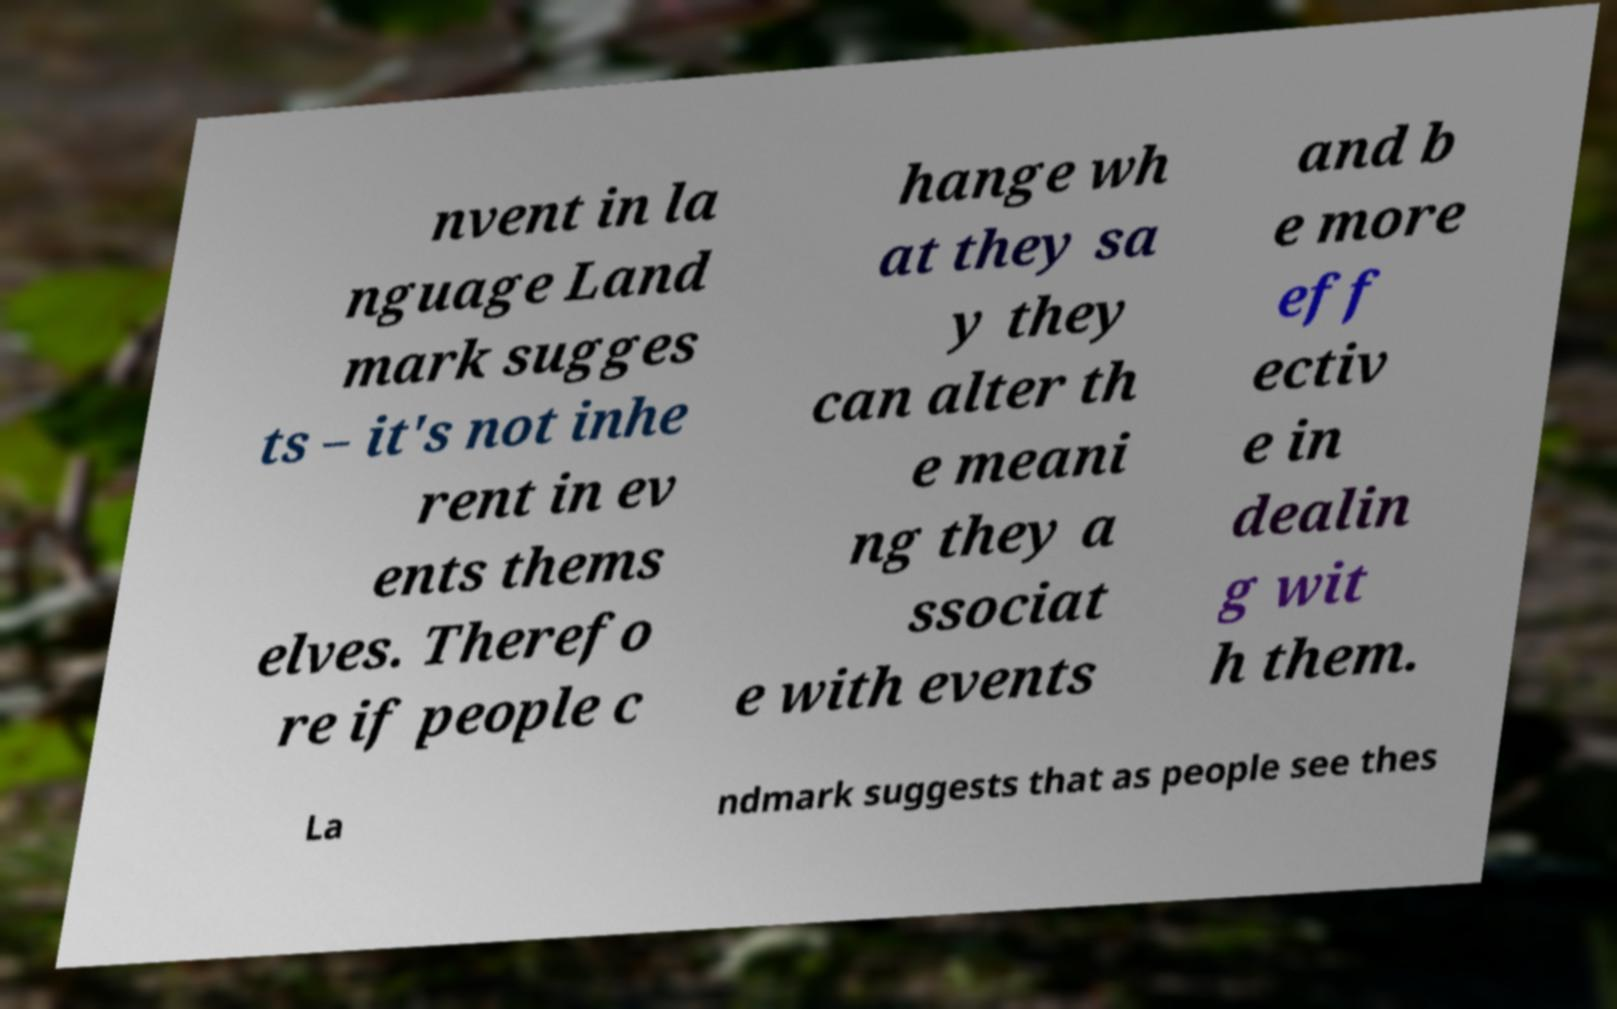There's text embedded in this image that I need extracted. Can you transcribe it verbatim? nvent in la nguage Land mark sugges ts – it's not inhe rent in ev ents thems elves. Therefo re if people c hange wh at they sa y they can alter th e meani ng they a ssociat e with events and b e more eff ectiv e in dealin g wit h them. La ndmark suggests that as people see thes 